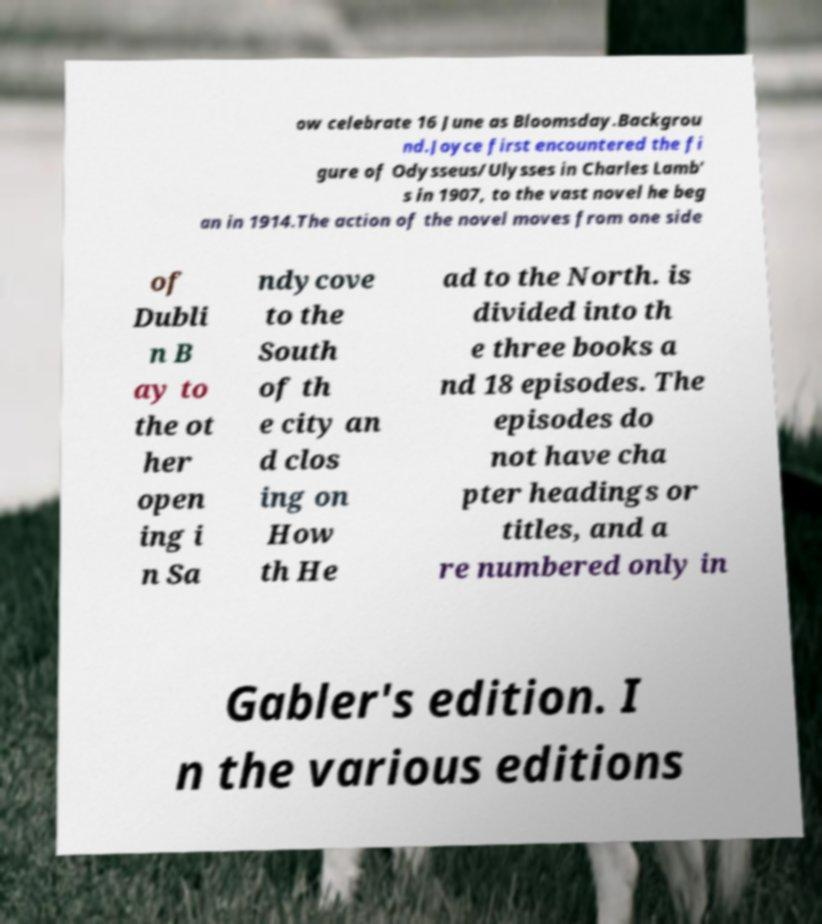There's text embedded in this image that I need extracted. Can you transcribe it verbatim? ow celebrate 16 June as Bloomsday.Backgrou nd.Joyce first encountered the fi gure of Odysseus/Ulysses in Charles Lamb' s in 1907, to the vast novel he beg an in 1914.The action of the novel moves from one side of Dubli n B ay to the ot her open ing i n Sa ndycove to the South of th e city an d clos ing on How th He ad to the North. is divided into th e three books a nd 18 episodes. The episodes do not have cha pter headings or titles, and a re numbered only in Gabler's edition. I n the various editions 